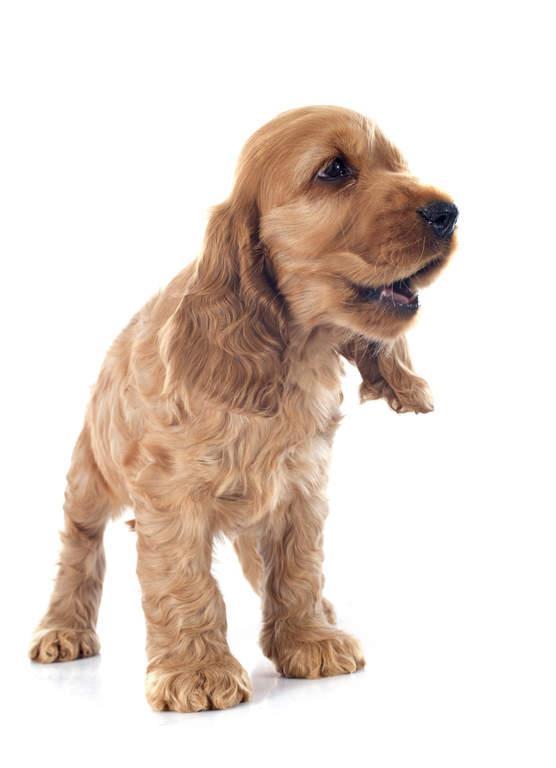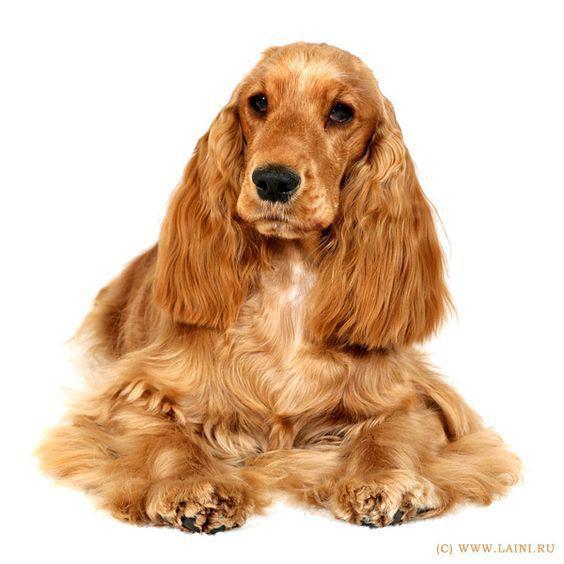The first image is the image on the left, the second image is the image on the right. Considering the images on both sides, is "One image contains a 'ginger' cocker spaniel sitting upright, and the other contains a 'ginger' cocker spaniel in a reclining pose." valid? Answer yes or no. No. The first image is the image on the left, the second image is the image on the right. For the images displayed, is the sentence "One dog is sitting and one is laying down." factually correct? Answer yes or no. No. 